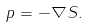<formula> <loc_0><loc_0><loc_500><loc_500>p = - \nabla S .</formula> 